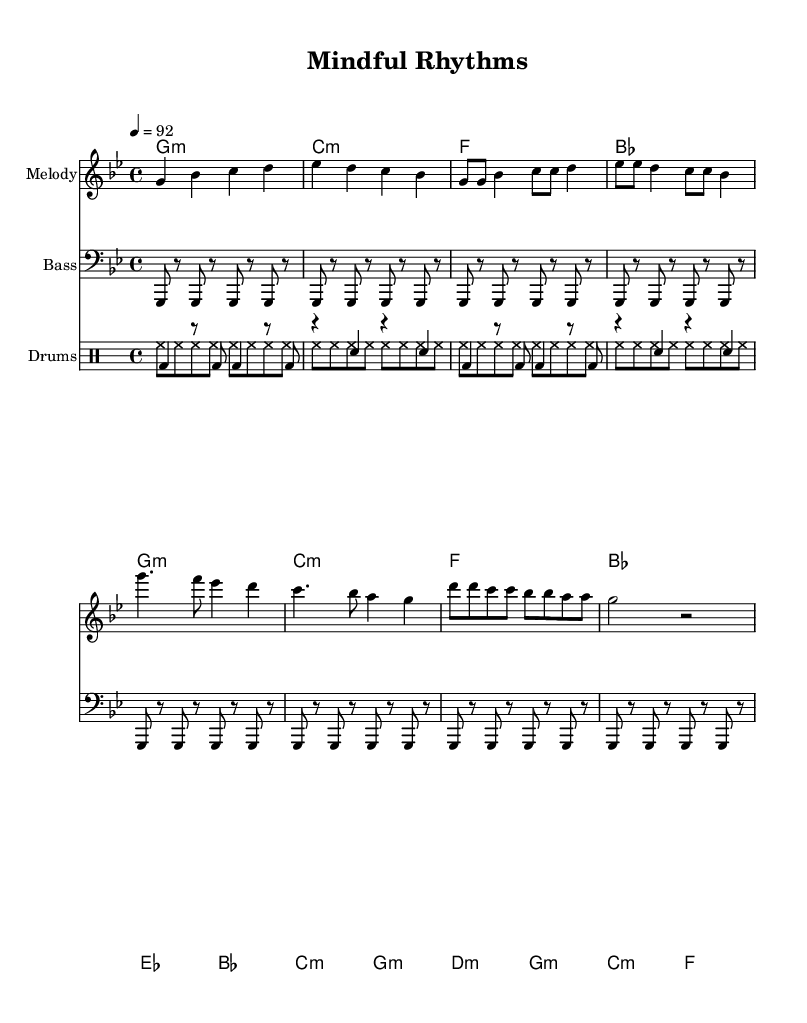What is the key signature of this music? The key signature is indicated by the two flats placed at the beginning of the staff. This corresponds to the key of G minor.
Answer: G minor What is the time signature of the music? The time signature is displayed as 4/4, which means there are four beats in each measure, and the quarter note receives one beat.
Answer: 4/4 What is the tempo marking for this piece? The tempo marking is indicated by the numerical value of 92 next to the word "tempo," meaning the piece is to be played at 92 beats per minute.
Answer: 92 How many measures are in the verse section? The verse section includes the part of the sheet music designated as "Verse," which contains 8 measures.
Answer: 8 What type of musical piece is this? This is labeled as a Hip Hop piece that incorporates educational elements and therapeutic concepts, indicated by the title "Mindful Rhythms."
Answer: Hip Hop Which instrument plays the melody? The melody is written on the top staff with the instrument name "Melody," indicating that the melody line is played by that instrument.
Answer: Melody What is the rhythm of the bass line in the first section? The bass line consists of a repeated rhythm of four eighth notes followed by rests in the first section, as shown in the lower staff.
Answer: Repeated eighth notes 